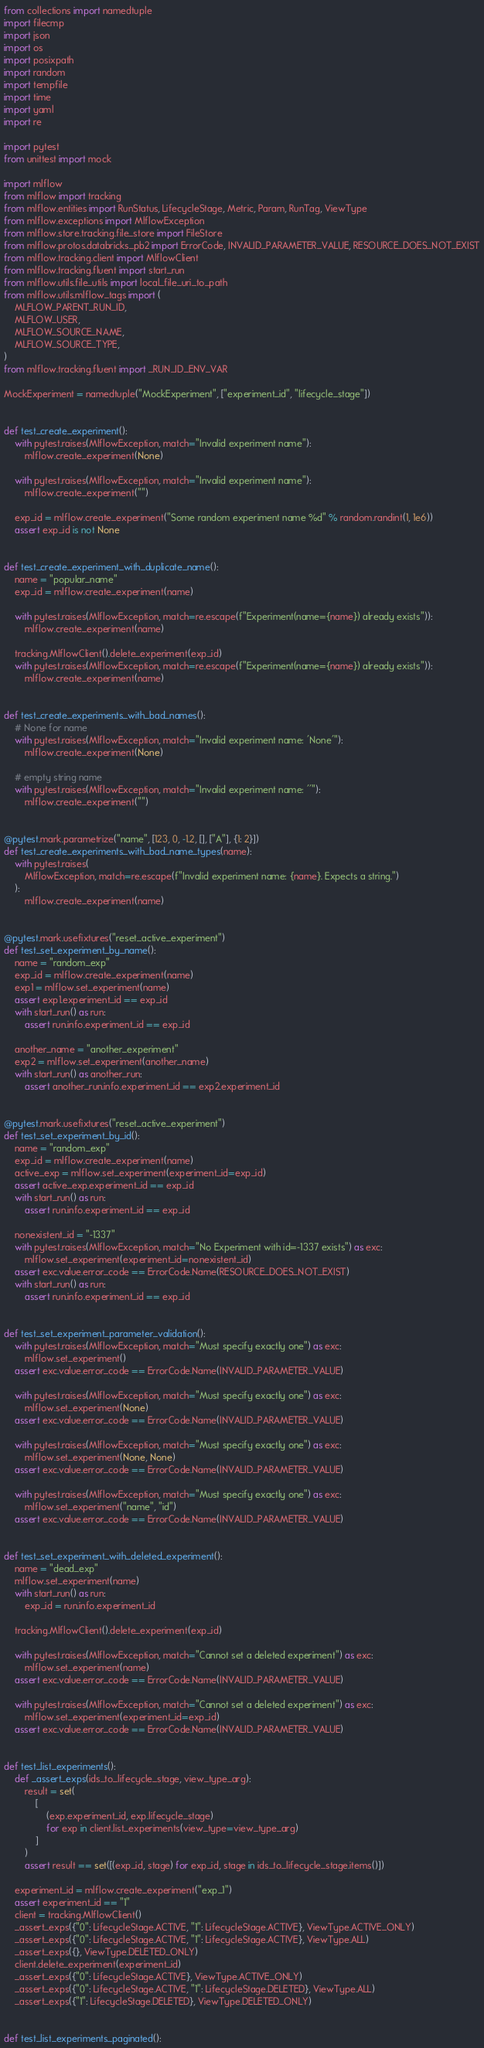<code> <loc_0><loc_0><loc_500><loc_500><_Python_>from collections import namedtuple
import filecmp
import json
import os
import posixpath
import random
import tempfile
import time
import yaml
import re

import pytest
from unittest import mock

import mlflow
from mlflow import tracking
from mlflow.entities import RunStatus, LifecycleStage, Metric, Param, RunTag, ViewType
from mlflow.exceptions import MlflowException
from mlflow.store.tracking.file_store import FileStore
from mlflow.protos.databricks_pb2 import ErrorCode, INVALID_PARAMETER_VALUE, RESOURCE_DOES_NOT_EXIST
from mlflow.tracking.client import MlflowClient
from mlflow.tracking.fluent import start_run
from mlflow.utils.file_utils import local_file_uri_to_path
from mlflow.utils.mlflow_tags import (
    MLFLOW_PARENT_RUN_ID,
    MLFLOW_USER,
    MLFLOW_SOURCE_NAME,
    MLFLOW_SOURCE_TYPE,
)
from mlflow.tracking.fluent import _RUN_ID_ENV_VAR

MockExperiment = namedtuple("MockExperiment", ["experiment_id", "lifecycle_stage"])


def test_create_experiment():
    with pytest.raises(MlflowException, match="Invalid experiment name"):
        mlflow.create_experiment(None)

    with pytest.raises(MlflowException, match="Invalid experiment name"):
        mlflow.create_experiment("")

    exp_id = mlflow.create_experiment("Some random experiment name %d" % random.randint(1, 1e6))
    assert exp_id is not None


def test_create_experiment_with_duplicate_name():
    name = "popular_name"
    exp_id = mlflow.create_experiment(name)

    with pytest.raises(MlflowException, match=re.escape(f"Experiment(name={name}) already exists")):
        mlflow.create_experiment(name)

    tracking.MlflowClient().delete_experiment(exp_id)
    with pytest.raises(MlflowException, match=re.escape(f"Experiment(name={name}) already exists")):
        mlflow.create_experiment(name)


def test_create_experiments_with_bad_names():
    # None for name
    with pytest.raises(MlflowException, match="Invalid experiment name: 'None'"):
        mlflow.create_experiment(None)

    # empty string name
    with pytest.raises(MlflowException, match="Invalid experiment name: ''"):
        mlflow.create_experiment("")


@pytest.mark.parametrize("name", [123, 0, -1.2, [], ["A"], {1: 2}])
def test_create_experiments_with_bad_name_types(name):
    with pytest.raises(
        MlflowException, match=re.escape(f"Invalid experiment name: {name}. Expects a string.")
    ):
        mlflow.create_experiment(name)


@pytest.mark.usefixtures("reset_active_experiment")
def test_set_experiment_by_name():
    name = "random_exp"
    exp_id = mlflow.create_experiment(name)
    exp1 = mlflow.set_experiment(name)
    assert exp1.experiment_id == exp_id
    with start_run() as run:
        assert run.info.experiment_id == exp_id

    another_name = "another_experiment"
    exp2 = mlflow.set_experiment(another_name)
    with start_run() as another_run:
        assert another_run.info.experiment_id == exp2.experiment_id


@pytest.mark.usefixtures("reset_active_experiment")
def test_set_experiment_by_id():
    name = "random_exp"
    exp_id = mlflow.create_experiment(name)
    active_exp = mlflow.set_experiment(experiment_id=exp_id)
    assert active_exp.experiment_id == exp_id
    with start_run() as run:
        assert run.info.experiment_id == exp_id

    nonexistent_id = "-1337"
    with pytest.raises(MlflowException, match="No Experiment with id=-1337 exists") as exc:
        mlflow.set_experiment(experiment_id=nonexistent_id)
    assert exc.value.error_code == ErrorCode.Name(RESOURCE_DOES_NOT_EXIST)
    with start_run() as run:
        assert run.info.experiment_id == exp_id


def test_set_experiment_parameter_validation():
    with pytest.raises(MlflowException, match="Must specify exactly one") as exc:
        mlflow.set_experiment()
    assert exc.value.error_code == ErrorCode.Name(INVALID_PARAMETER_VALUE)

    with pytest.raises(MlflowException, match="Must specify exactly one") as exc:
        mlflow.set_experiment(None)
    assert exc.value.error_code == ErrorCode.Name(INVALID_PARAMETER_VALUE)

    with pytest.raises(MlflowException, match="Must specify exactly one") as exc:
        mlflow.set_experiment(None, None)
    assert exc.value.error_code == ErrorCode.Name(INVALID_PARAMETER_VALUE)

    with pytest.raises(MlflowException, match="Must specify exactly one") as exc:
        mlflow.set_experiment("name", "id")
    assert exc.value.error_code == ErrorCode.Name(INVALID_PARAMETER_VALUE)


def test_set_experiment_with_deleted_experiment():
    name = "dead_exp"
    mlflow.set_experiment(name)
    with start_run() as run:
        exp_id = run.info.experiment_id

    tracking.MlflowClient().delete_experiment(exp_id)

    with pytest.raises(MlflowException, match="Cannot set a deleted experiment") as exc:
        mlflow.set_experiment(name)
    assert exc.value.error_code == ErrorCode.Name(INVALID_PARAMETER_VALUE)

    with pytest.raises(MlflowException, match="Cannot set a deleted experiment") as exc:
        mlflow.set_experiment(experiment_id=exp_id)
    assert exc.value.error_code == ErrorCode.Name(INVALID_PARAMETER_VALUE)


def test_list_experiments():
    def _assert_exps(ids_to_lifecycle_stage, view_type_arg):
        result = set(
            [
                (exp.experiment_id, exp.lifecycle_stage)
                for exp in client.list_experiments(view_type=view_type_arg)
            ]
        )
        assert result == set([(exp_id, stage) for exp_id, stage in ids_to_lifecycle_stage.items()])

    experiment_id = mlflow.create_experiment("exp_1")
    assert experiment_id == "1"
    client = tracking.MlflowClient()
    _assert_exps({"0": LifecycleStage.ACTIVE, "1": LifecycleStage.ACTIVE}, ViewType.ACTIVE_ONLY)
    _assert_exps({"0": LifecycleStage.ACTIVE, "1": LifecycleStage.ACTIVE}, ViewType.ALL)
    _assert_exps({}, ViewType.DELETED_ONLY)
    client.delete_experiment(experiment_id)
    _assert_exps({"0": LifecycleStage.ACTIVE}, ViewType.ACTIVE_ONLY)
    _assert_exps({"0": LifecycleStage.ACTIVE, "1": LifecycleStage.DELETED}, ViewType.ALL)
    _assert_exps({"1": LifecycleStage.DELETED}, ViewType.DELETED_ONLY)


def test_list_experiments_paginated():</code> 